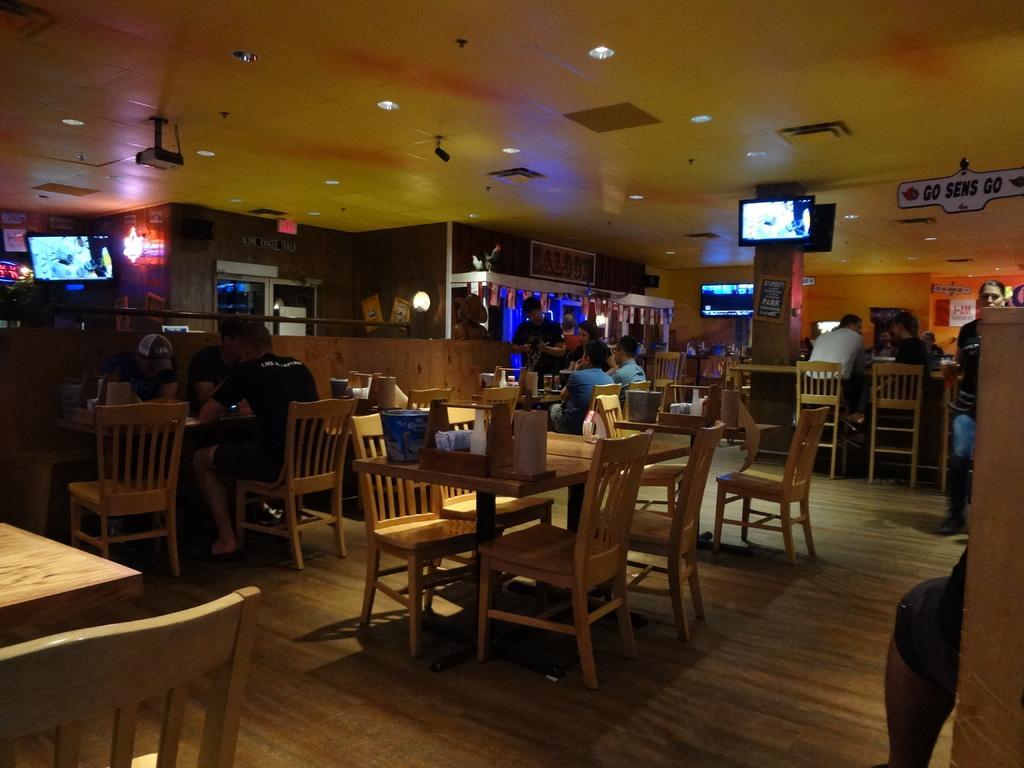Describe this image in one or two sentences. A room which has some chairs and table and on the table we can see some items and people sitting on the chairs and we can see two screens. 